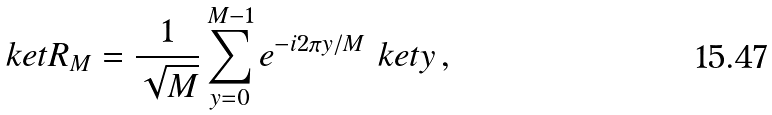Convert formula to latex. <formula><loc_0><loc_0><loc_500><loc_500>\ k e t { R _ { M } } = \frac { 1 } { \sqrt { M } } \sum _ { y = 0 } ^ { M - 1 } e ^ { - i 2 \pi y / M } \ k e t { y } \, ,</formula> 